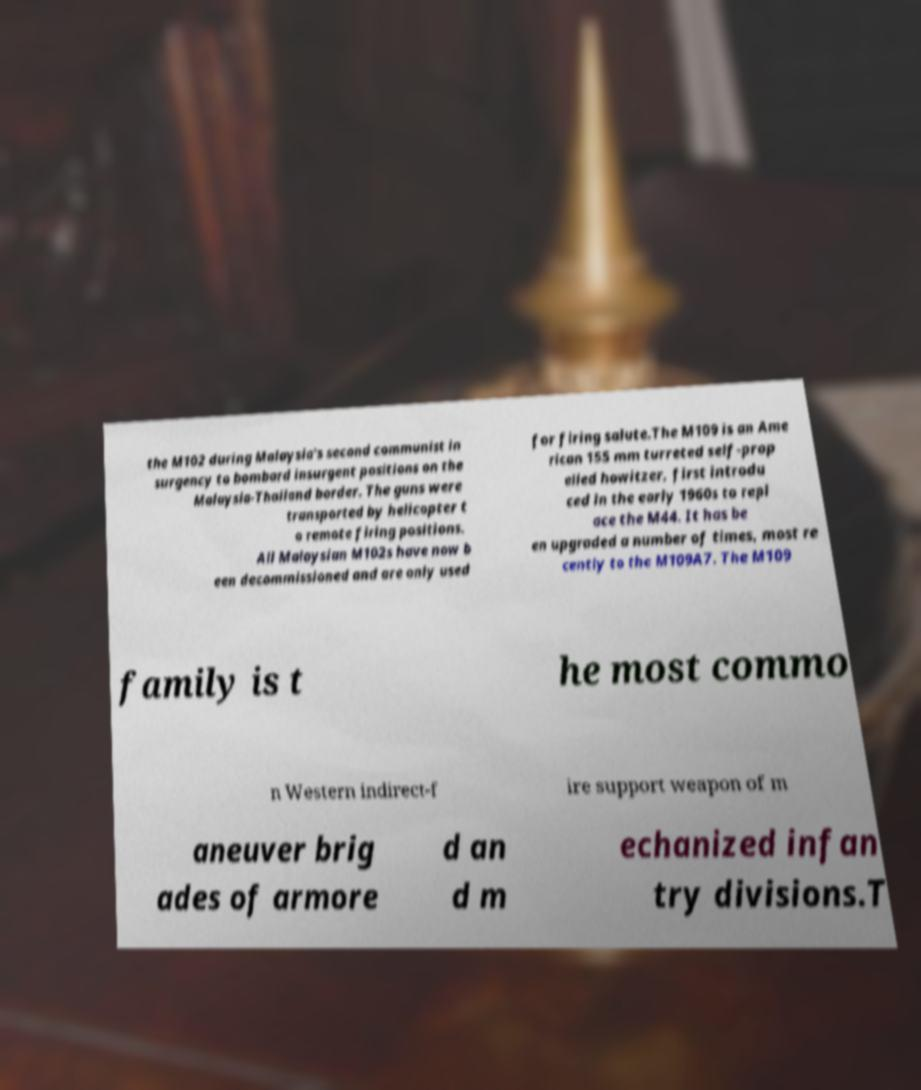Can you read and provide the text displayed in the image?This photo seems to have some interesting text. Can you extract and type it out for me? the M102 during Malaysia's second communist in surgency to bombard insurgent positions on the Malaysia-Thailand border. The guns were transported by helicopter t o remote firing positions. All Malaysian M102s have now b een decommissioned and are only used for firing salute.The M109 is an Ame rican 155 mm turreted self-prop elled howitzer, first introdu ced in the early 1960s to repl ace the M44. It has be en upgraded a number of times, most re cently to the M109A7. The M109 family is t he most commo n Western indirect-f ire support weapon of m aneuver brig ades of armore d an d m echanized infan try divisions.T 